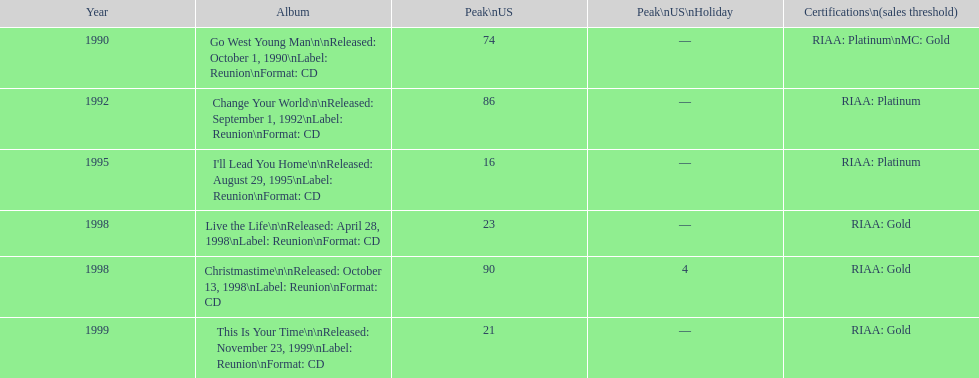How many songs are listed from 1998? 2. 